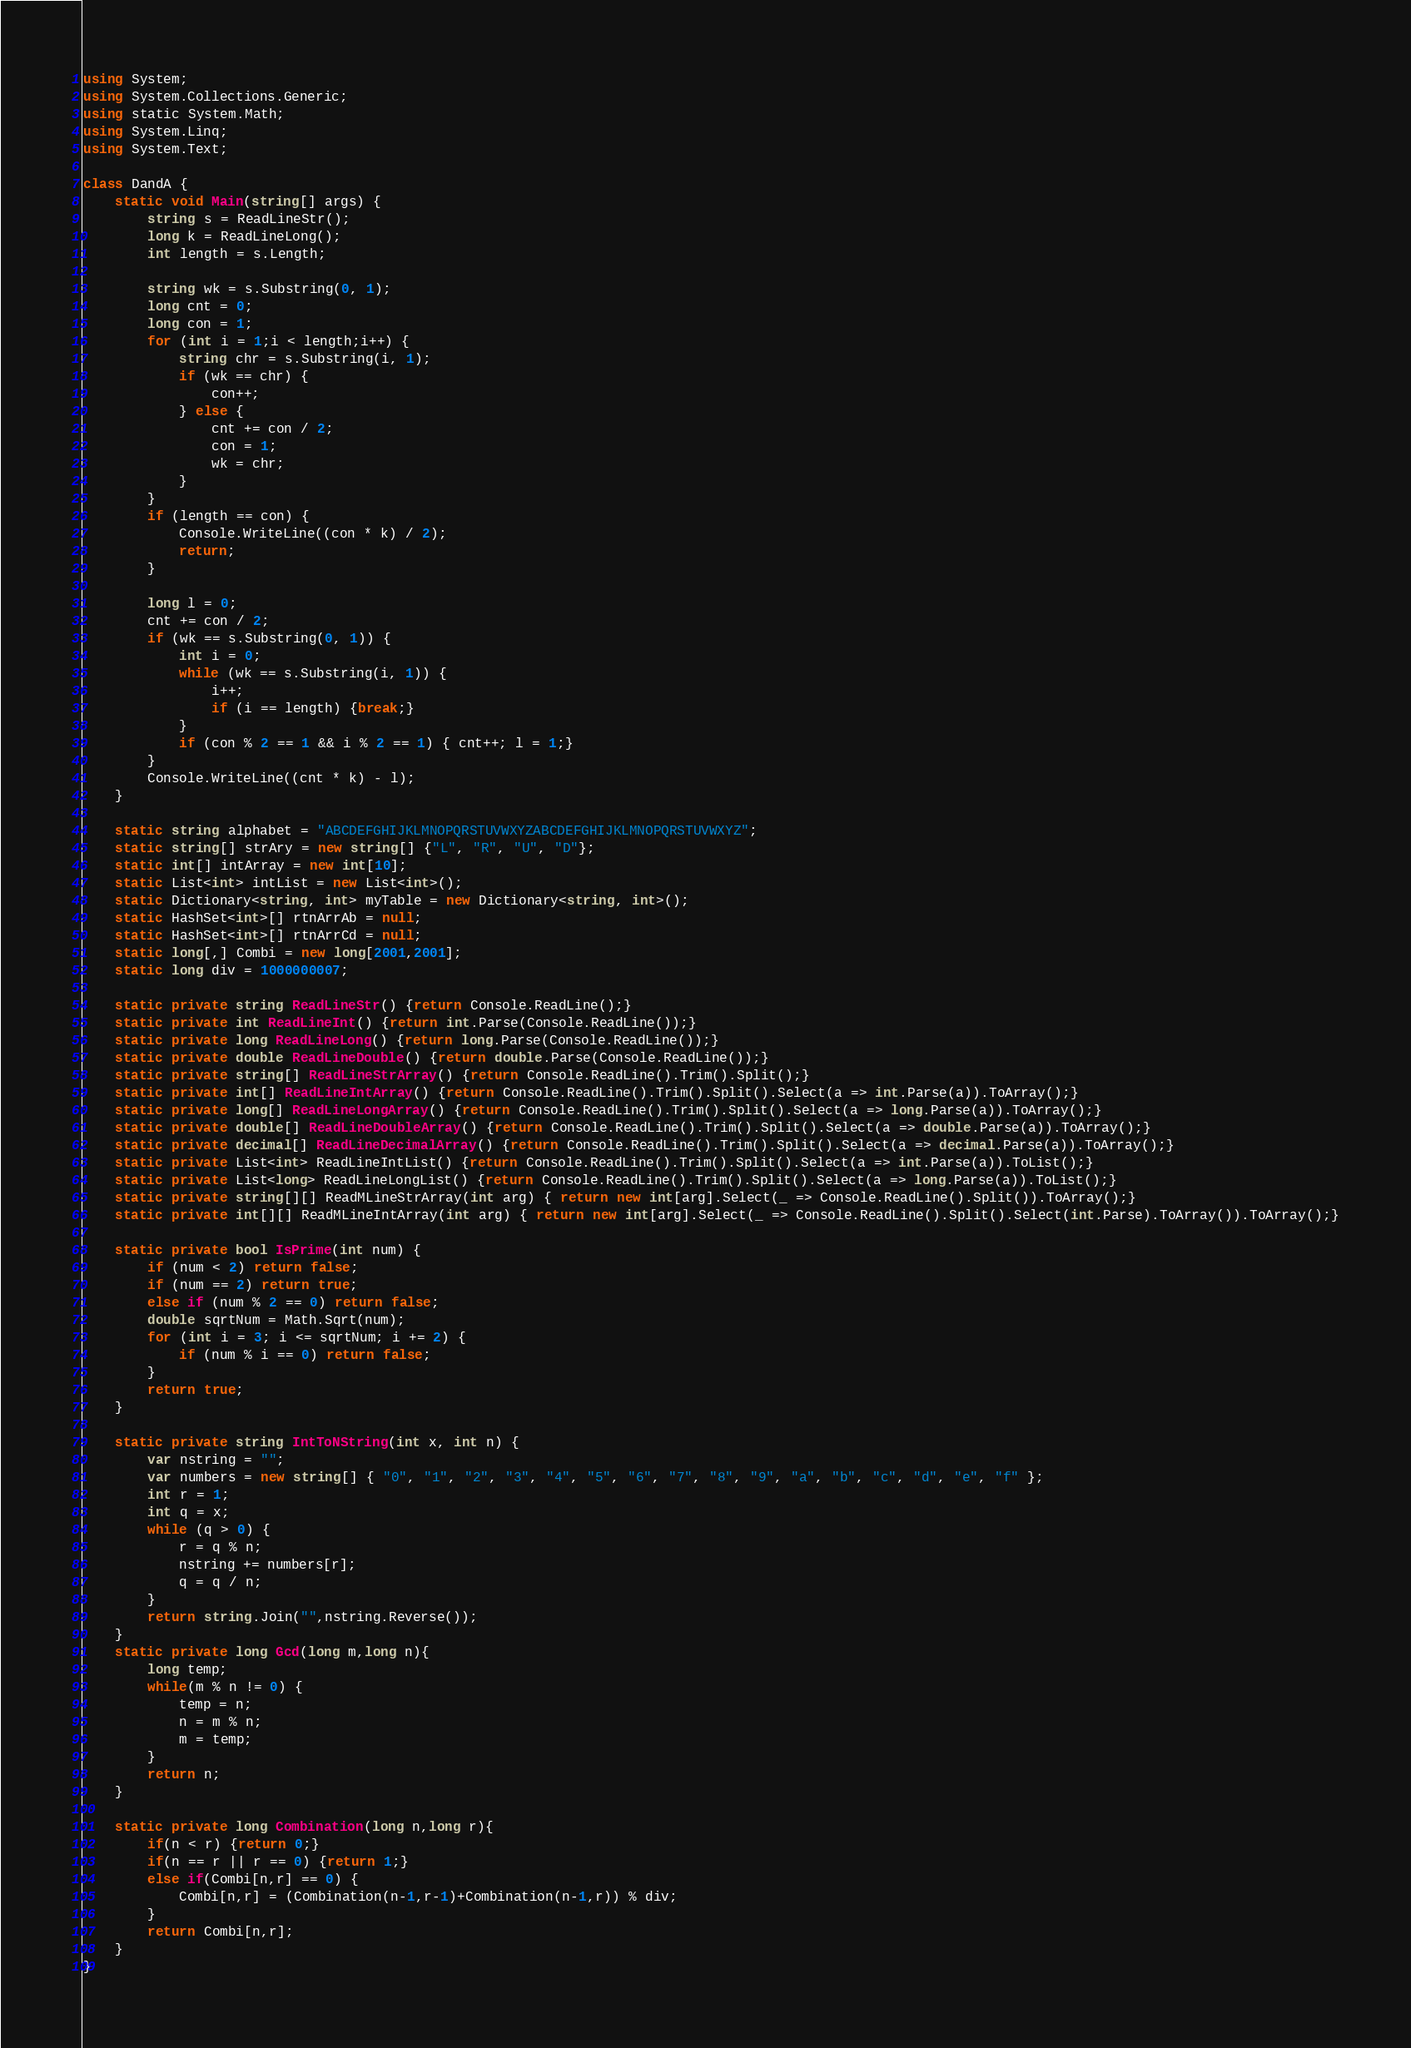<code> <loc_0><loc_0><loc_500><loc_500><_C#_>using System;
using System.Collections.Generic;
using static System.Math;
using System.Linq;
using System.Text;
 
class DandA {
    static void Main(string[] args) {
        string s = ReadLineStr();
        long k = ReadLineLong();
        int length = s.Length;

        string wk = s.Substring(0, 1);
        long cnt = 0;
        long con = 1;
        for (int i = 1;i < length;i++) {
            string chr = s.Substring(i, 1);
            if (wk == chr) {
                con++;
            } else {
                cnt += con / 2;
                con = 1;
                wk = chr;
            }
        }
        if (length == con) {
            Console.WriteLine((con * k) / 2);
            return;
        }
        
        long l = 0;
        cnt += con / 2;
        if (wk == s.Substring(0, 1)) {
            int i = 0;
            while (wk == s.Substring(i, 1)) {
                i++;
                if (i == length) {break;}
            }
            if (con % 2 == 1 && i % 2 == 1) { cnt++; l = 1;}
        }
        Console.WriteLine((cnt * k) - l);
    }
 
    static string alphabet = "ABCDEFGHIJKLMNOPQRSTUVWXYZABCDEFGHIJKLMNOPQRSTUVWXYZ";
    static string[] strAry = new string[] {"L", "R", "U", "D"};
    static int[] intArray = new int[10];
    static List<int> intList = new List<int>();
    static Dictionary<string, int> myTable = new Dictionary<string, int>();
    static HashSet<int>[] rtnArrAb = null;
    static HashSet<int>[] rtnArrCd = null;
    static long[,] Combi = new long[2001,2001];
    static long div = 1000000007;
  
    static private string ReadLineStr() {return Console.ReadLine();}
    static private int ReadLineInt() {return int.Parse(Console.ReadLine());}
    static private long ReadLineLong() {return long.Parse(Console.ReadLine());}
    static private double ReadLineDouble() {return double.Parse(Console.ReadLine());}
    static private string[] ReadLineStrArray() {return Console.ReadLine().Trim().Split();}
    static private int[] ReadLineIntArray() {return Console.ReadLine().Trim().Split().Select(a => int.Parse(a)).ToArray();}
    static private long[] ReadLineLongArray() {return Console.ReadLine().Trim().Split().Select(a => long.Parse(a)).ToArray();}
    static private double[] ReadLineDoubleArray() {return Console.ReadLine().Trim().Split().Select(a => double.Parse(a)).ToArray();}
    static private decimal[] ReadLineDecimalArray() {return Console.ReadLine().Trim().Split().Select(a => decimal.Parse(a)).ToArray();}
    static private List<int> ReadLineIntList() {return Console.ReadLine().Trim().Split().Select(a => int.Parse(a)).ToList();}
    static private List<long> ReadLineLongList() {return Console.ReadLine().Trim().Split().Select(a => long.Parse(a)).ToList();}
    static private string[][] ReadMLineStrArray(int arg) { return new int[arg].Select(_ => Console.ReadLine().Split()).ToArray();}
    static private int[][] ReadMLineIntArray(int arg) { return new int[arg].Select(_ => Console.ReadLine().Split().Select(int.Parse).ToArray()).ToArray();}
 
    static private bool IsPrime(int num) {
        if (num < 2) return false;
        if (num == 2) return true;
        else if (num % 2 == 0) return false;
        double sqrtNum = Math.Sqrt(num);
        for (int i = 3; i <= sqrtNum; i += 2) {
            if (num % i == 0) return false;
        }
        return true;
    }
  
    static private string IntToNString(int x, int n) {
        var nstring = "";
        var numbers = new string[] { "0", "1", "2", "3", "4", "5", "6", "7", "8", "9", "a", "b", "c", "d", "e", "f" };
        int r = 1;
        int q = x;
        while (q > 0) {
            r = q % n;
            nstring += numbers[r];
            q = q / n;
        }
        return string.Join("",nstring.Reverse());
    }
    static private long Gcd(long m,long n){
        long temp;
        while(m % n != 0) {
            temp = n;
            n = m % n;
            m = temp;
        }
        return n;
    }
 
    static private long Combination(long n,long r){
        if(n < r) {return 0;}
        if(n == r || r == 0) {return 1;}
        else if(Combi[n,r] == 0) {
            Combi[n,r] = (Combination(n-1,r-1)+Combination(n-1,r)) % div;
        }
        return Combi[n,r];
    }
}</code> 